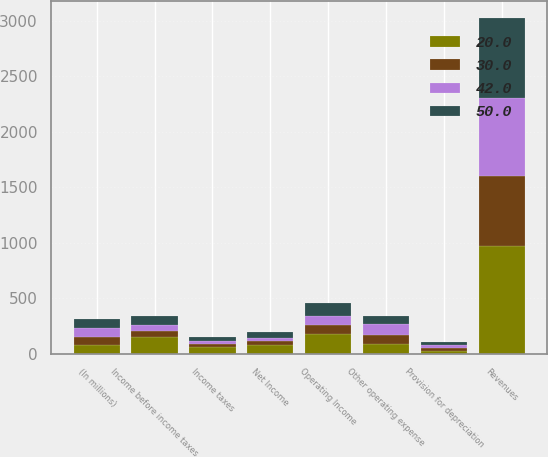Convert chart. <chart><loc_0><loc_0><loc_500><loc_500><stacked_bar_chart><ecel><fcel>(In millions)<fcel>Revenues<fcel>Other operating expense<fcel>Provision for depreciation<fcel>Operating Income<fcel>Income before income taxes<fcel>Income taxes<fcel>Net Income<nl><fcel>42<fcel>77.5<fcel>704<fcel>96<fcel>28<fcel>80<fcel>53<fcel>24<fcel>29<nl><fcel>50<fcel>77.5<fcel>721<fcel>75<fcel>27<fcel>112<fcel>83<fcel>34<fcel>50<nl><fcel>20<fcel>77.5<fcel>968<fcel>89<fcel>27<fcel>176<fcel>147<fcel>64<fcel>83<nl><fcel>30<fcel>77.5<fcel>634<fcel>84<fcel>26<fcel>85<fcel>57<fcel>26<fcel>30<nl></chart> 